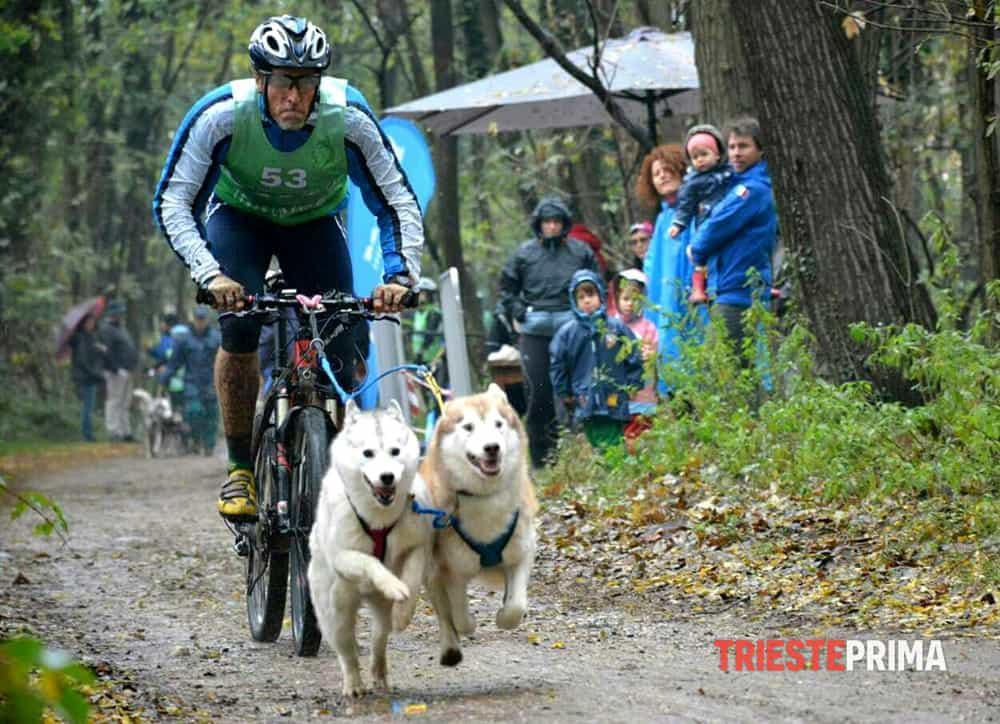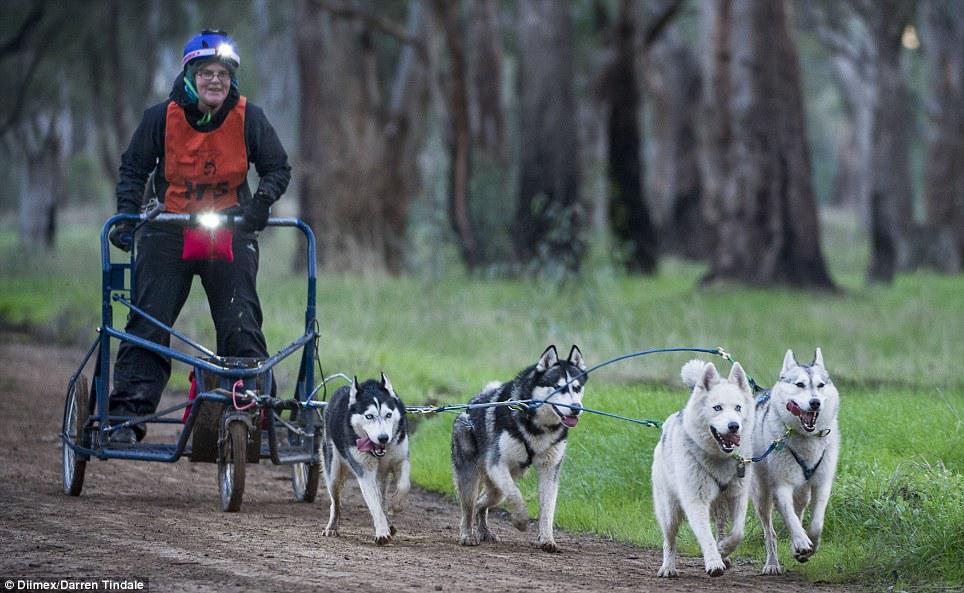The first image is the image on the left, the second image is the image on the right. For the images shown, is this caption "Someone is riding a bike while dogs run with them." true? Answer yes or no. Yes. The first image is the image on the left, the second image is the image on the right. For the images displayed, is the sentence "At least one image shows sled dogs moving across a snowy ground." factually correct? Answer yes or no. No. 